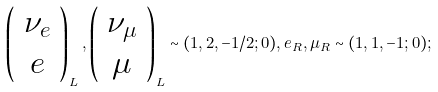Convert formula to latex. <formula><loc_0><loc_0><loc_500><loc_500>\left ( \begin{array} { c } \nu _ { e } \\ e \end{array} \right ) _ { L } , \left ( \begin{array} { c } \nu _ { \mu } \\ \mu \end{array} \right ) _ { L } \sim ( 1 , 2 , - 1 / 2 ; 0 ) , e _ { R } , \mu _ { R } \sim ( 1 , 1 , - 1 ; 0 ) ;</formula> 